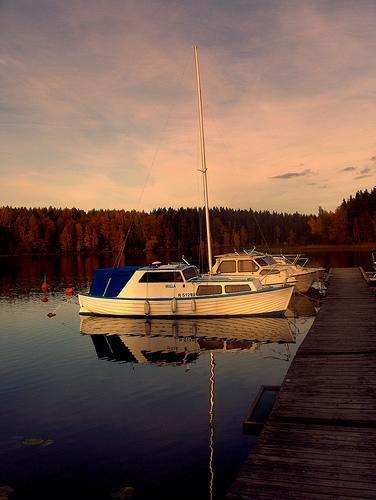How many elephants are pictured?
Give a very brief answer. 0. How many dinosaurs are in the picture?
Give a very brief answer. 0. How many boats are visible?
Give a very brief answer. 2. How many boats are clearly seen, docked?
Give a very brief answer. 2. How many people are sitting on top of the boats?
Give a very brief answer. 0. 